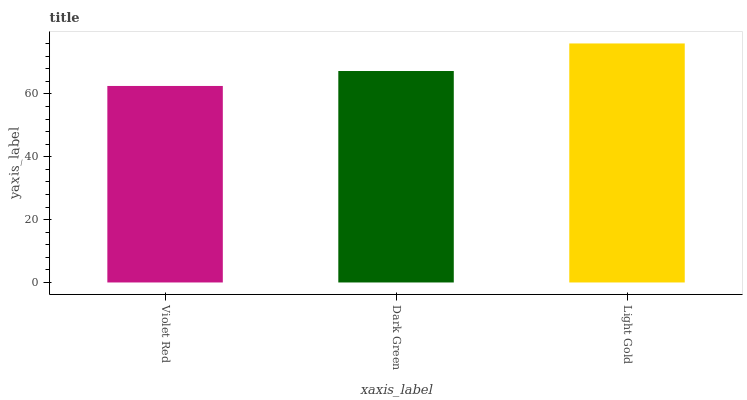Is Violet Red the minimum?
Answer yes or no. Yes. Is Light Gold the maximum?
Answer yes or no. Yes. Is Dark Green the minimum?
Answer yes or no. No. Is Dark Green the maximum?
Answer yes or no. No. Is Dark Green greater than Violet Red?
Answer yes or no. Yes. Is Violet Red less than Dark Green?
Answer yes or no. Yes. Is Violet Red greater than Dark Green?
Answer yes or no. No. Is Dark Green less than Violet Red?
Answer yes or no. No. Is Dark Green the high median?
Answer yes or no. Yes. Is Dark Green the low median?
Answer yes or no. Yes. Is Violet Red the high median?
Answer yes or no. No. Is Light Gold the low median?
Answer yes or no. No. 